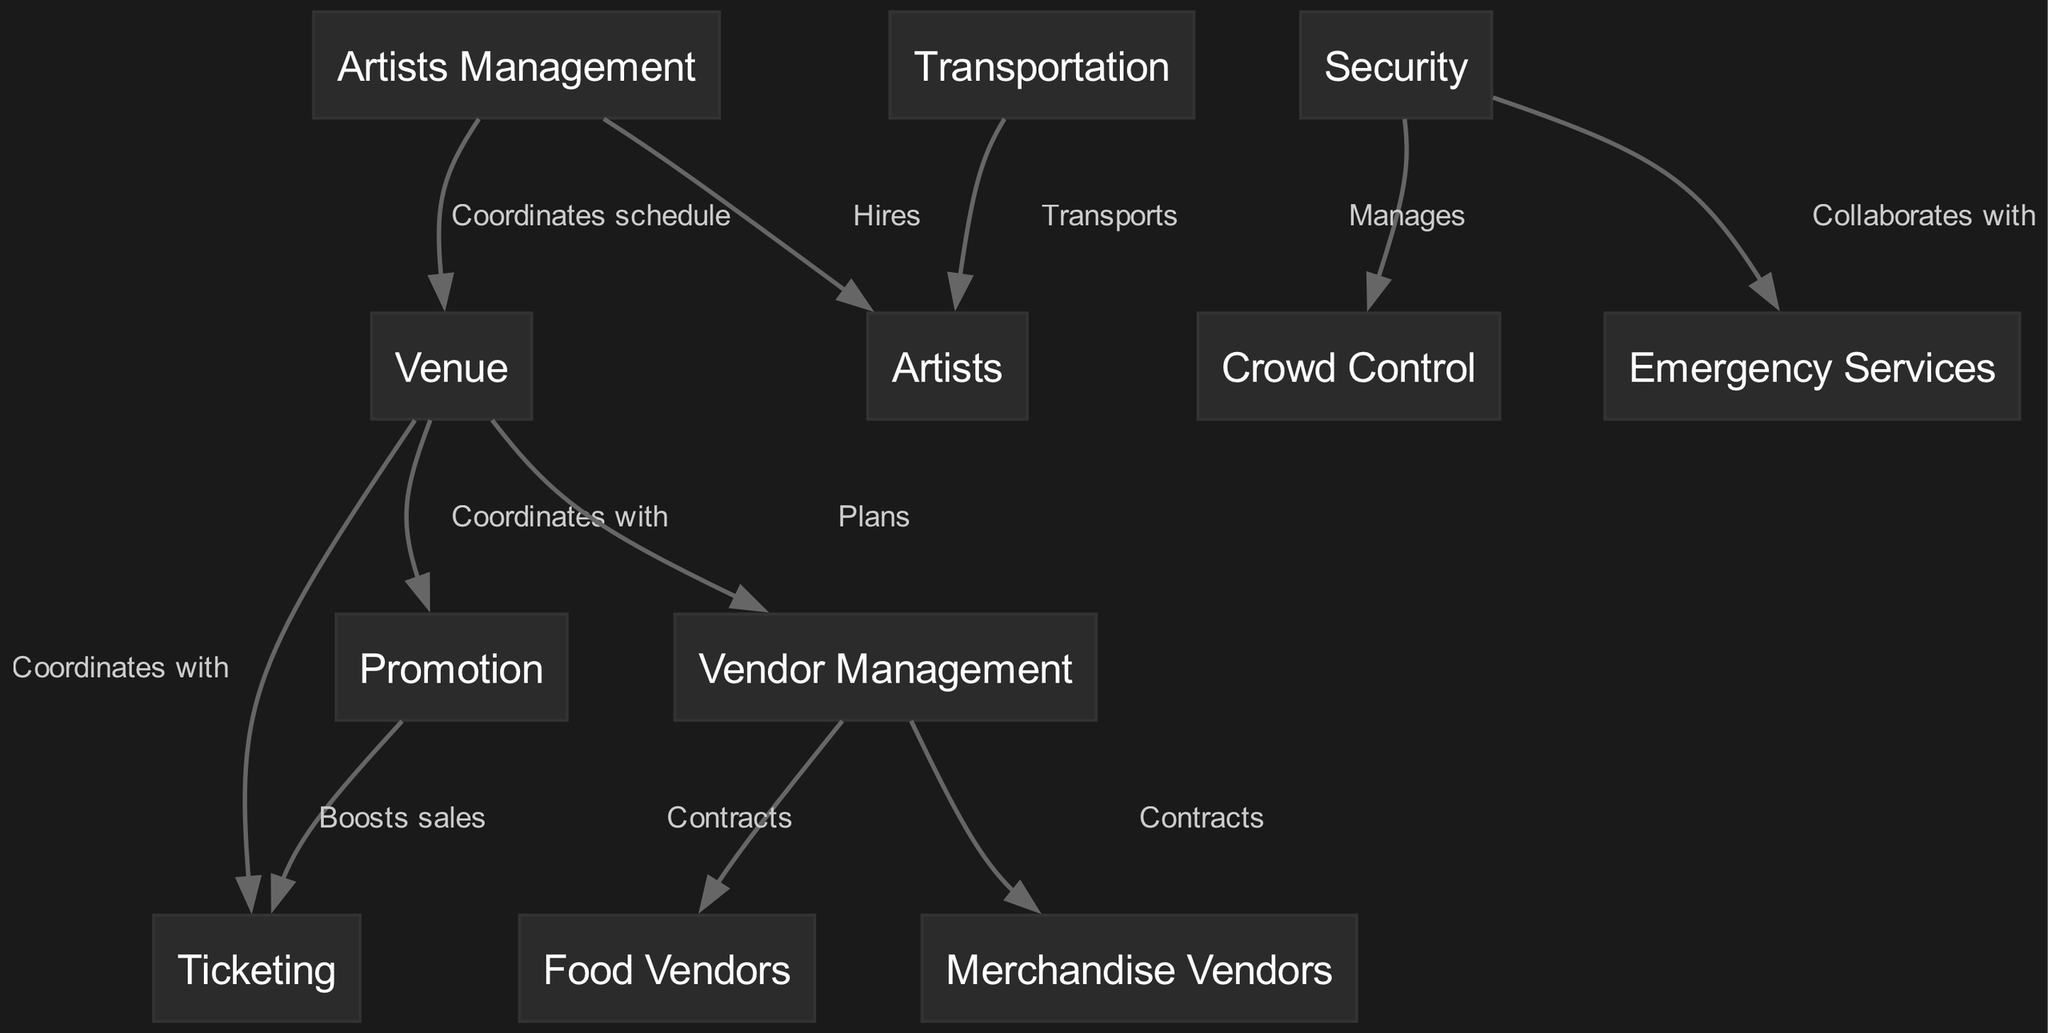What is the total number of nodes in this supply chain? The diagram lists several distinct elements involved in the supply chain. By counting them, we find that there are 12 unique nodes represented.
Answer: 12 Which node is responsible for transporting the artists? The diagram indicates that the node "Transportation" is connected to "Artists" with the label "Transports," signifying its responsibility in the supply chain.
Answer: Transportation How many edges connect the "Security" node to other nodes? Analyzing the edges connected to "Security," we find it connects to "Crowd Control" and "Emergency Services," which totals to two distinct connections.
Answer: 2 What role does "Promotion" play in relation to "Ticketing"? The edge between "Promotion" and "Ticketing" shows a connection labeled "Boosts sales," indicating that Promotion enhances ticket sales in the supply chain.
Answer: Boosts sales Which node does "Vendor Management" contract with for food supplies? The edge labeled "Contracts" between "Vendor Management" and "Food Vendors" directly indicates that Vendor Management is responsible for contracting food suppliers.
Answer: Food Vendors Which two functions does the "Security" node collaborate with? Upon examining the diagram, the "Security" node is connected to "Crowd Control" and "Emergency Services," indicating that its collaboration spans these two functions.
Answer: Crowd Control and Emergency Services What is the relationship between "Artists Management" and "Venue"? The edge labeled "Coordinates schedule" between "Artists Management" and "Venue" highlights that Artists Management coordinates the scheduling aspect with the venue for the festival.
Answer: Coordinates schedule Who manages crowd control according to the diagram? The edge from "Security" to "Crowd Control" labeled "Manages" clearly identifies that the Security node is tasked with managing crowd control at the festival.
Answer: Security What is the main responsibility of the "Vendor Management" node? The diagram demonstrates that Vendor Management "Plans" the inclusion of vendors as well as "Contracts" Food and Merchandise Vendors, showcasing its role in vendor coordination.
Answer: Plans and Contracts 